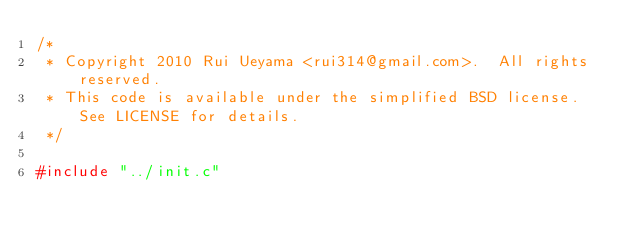Convert code to text. <code><loc_0><loc_0><loc_500><loc_500><_C_>/*
 * Copyright 2010 Rui Ueyama <rui314@gmail.com>.  All rights reserved.
 * This code is available under the simplified BSD license.  See LICENSE for details.
 */

#include "../init.c"
</code> 